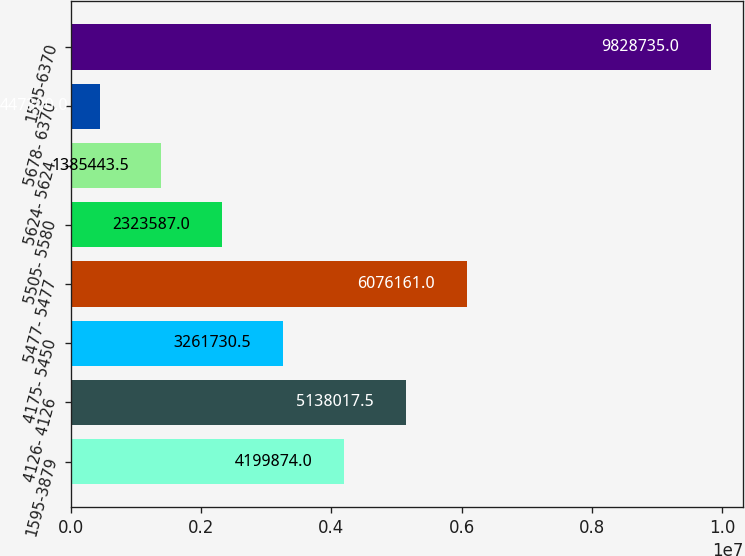Convert chart. <chart><loc_0><loc_0><loc_500><loc_500><bar_chart><fcel>1595-3879<fcel>4126- 4126<fcel>4175- 5450<fcel>5477- 5477<fcel>5505- 5580<fcel>5624- 5624<fcel>5678- 6370<fcel>1595-6370<nl><fcel>4.19987e+06<fcel>5.13802e+06<fcel>3.26173e+06<fcel>6.07616e+06<fcel>2.32359e+06<fcel>1.38544e+06<fcel>447300<fcel>9.82874e+06<nl></chart> 